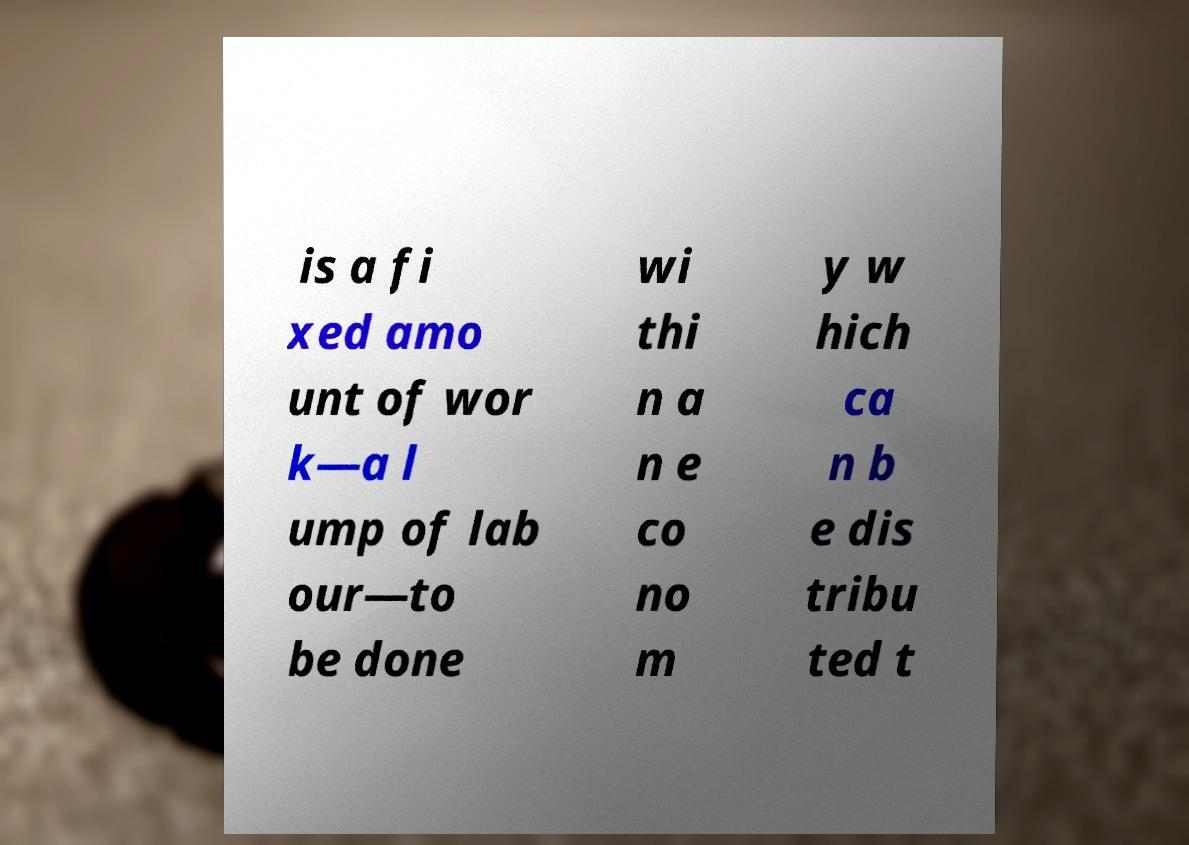Can you accurately transcribe the text from the provided image for me? is a fi xed amo unt of wor k—a l ump of lab our—to be done wi thi n a n e co no m y w hich ca n b e dis tribu ted t 